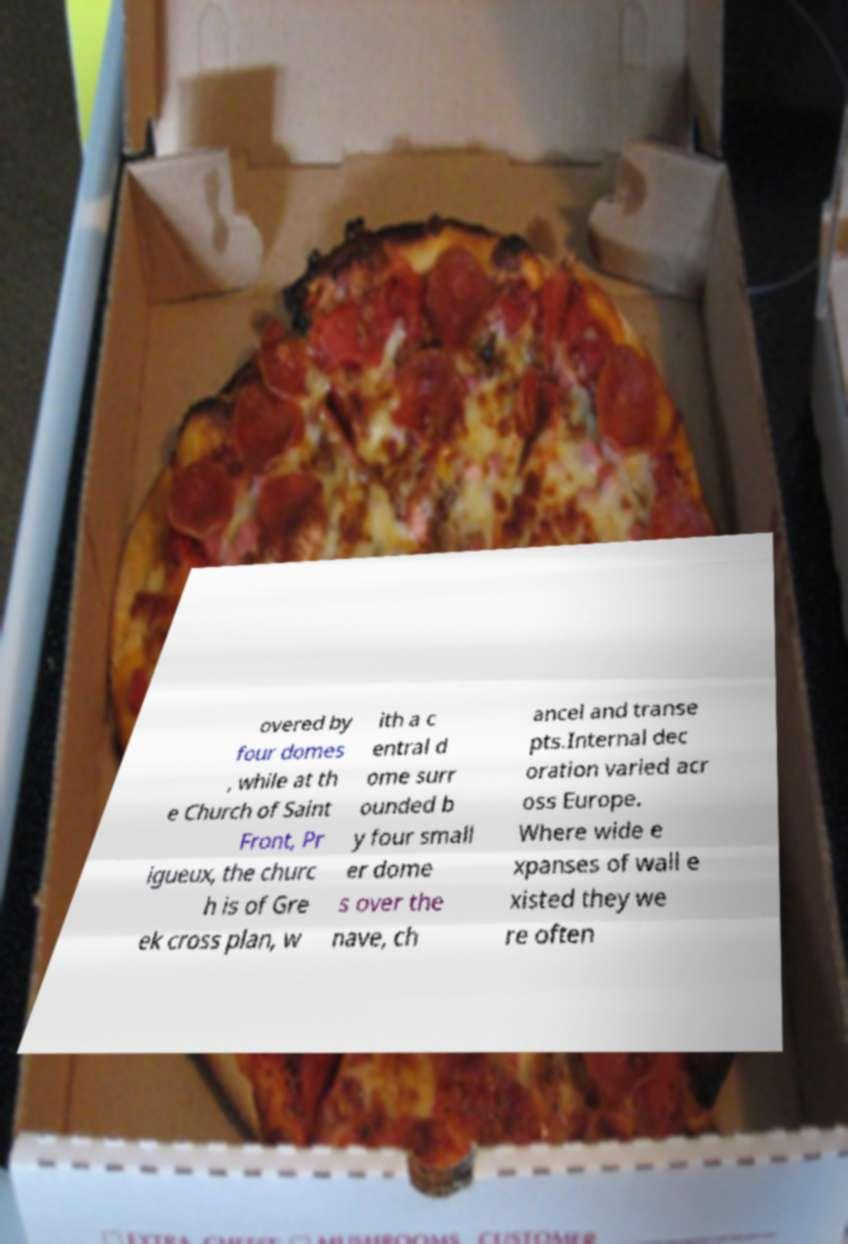For documentation purposes, I need the text within this image transcribed. Could you provide that? overed by four domes , while at th e Church of Saint Front, Pr igueux, the churc h is of Gre ek cross plan, w ith a c entral d ome surr ounded b y four small er dome s over the nave, ch ancel and transe pts.Internal dec oration varied acr oss Europe. Where wide e xpanses of wall e xisted they we re often 